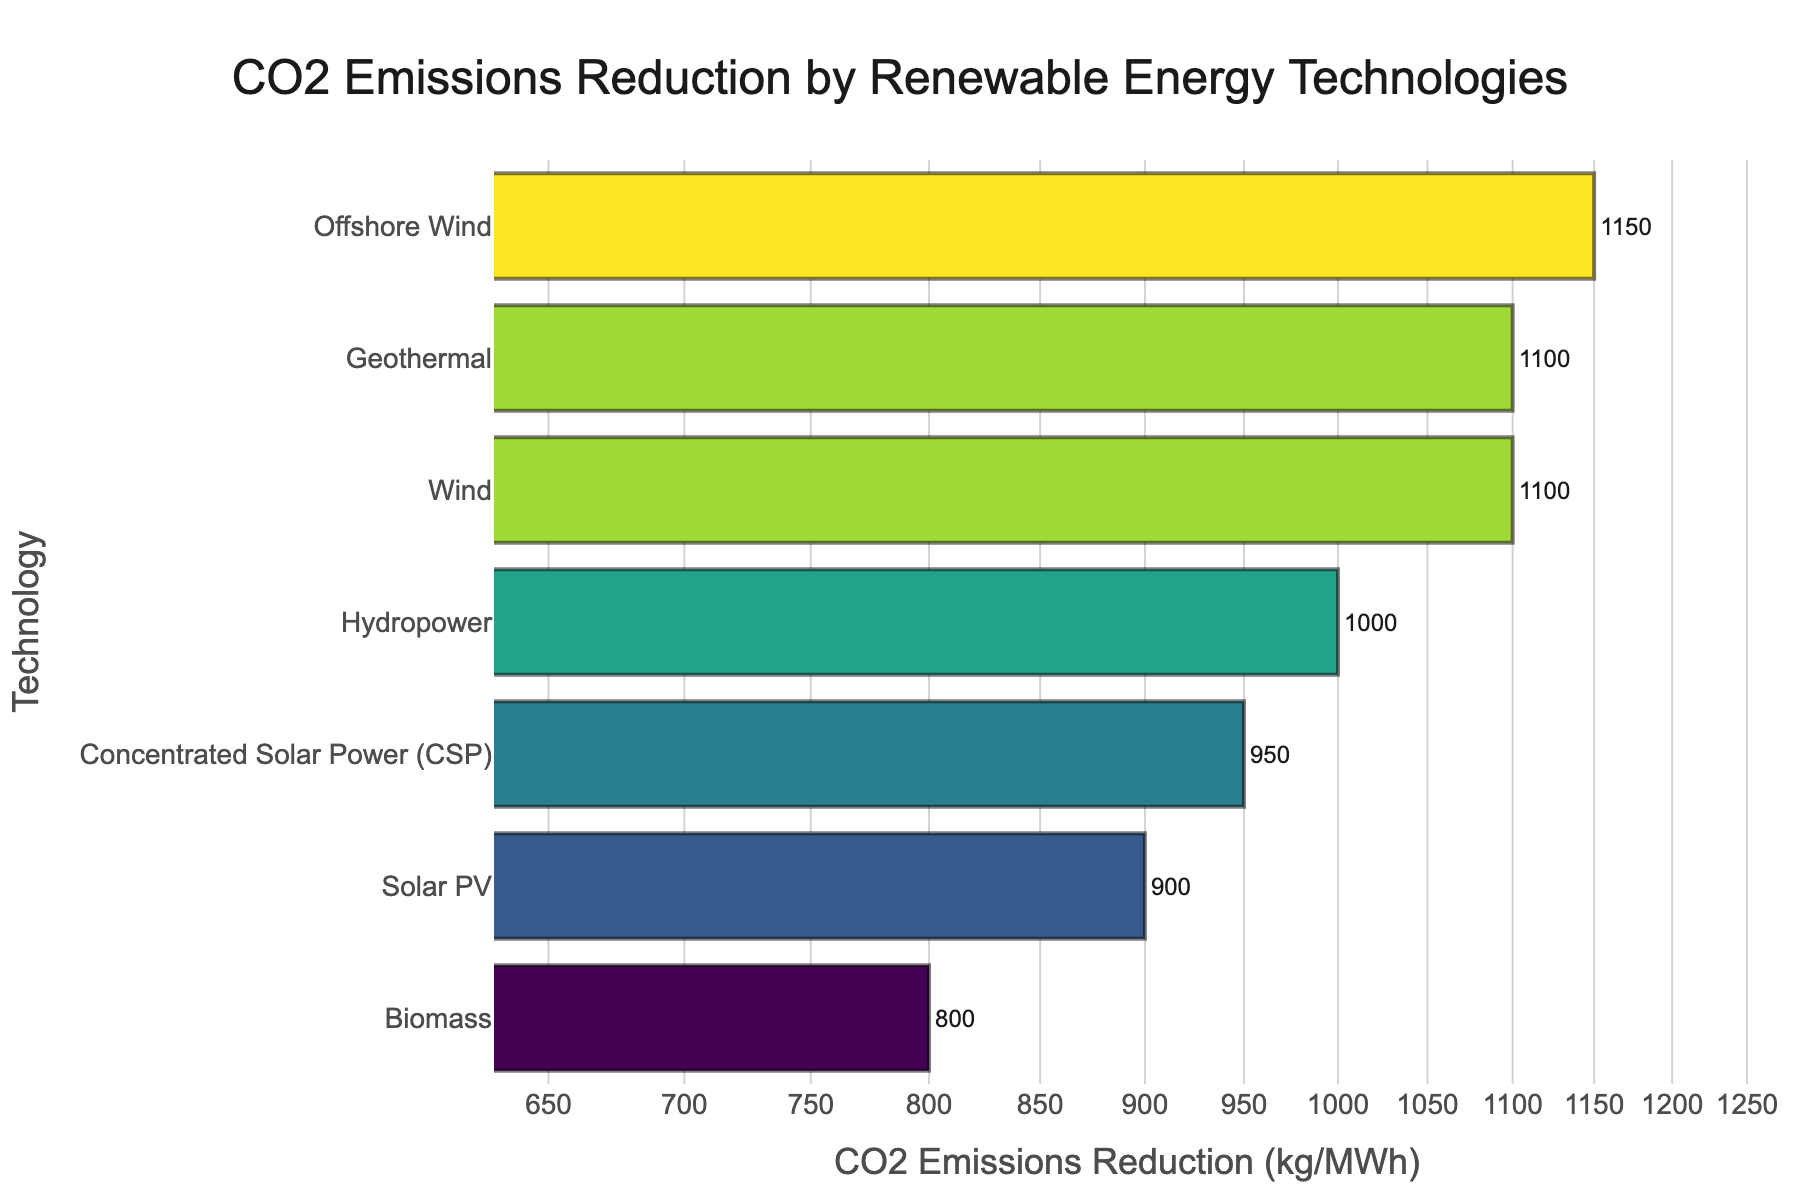What is the title of the figure? The title of the figure is prominently displayed at the top.
Answer: CO2 Emissions Reduction by Renewable Energy Technologies Which technology achieves the highest CO2 emissions reduction? The technology with the highest CO2 emissions reduction is positioned at the far right of the plot's x-axis.
Answer: Offshore Wind How many technologies have CO2 emissions reductions greater than 1000 kg/MWh? Count the number of bars where the CO2 emissions reduction exceeds 1000 kg/MWh.
Answer: 3 Which two technologies have exactly the same amount of CO2 emissions reduction? Identify the technologies with bars that align at the same x-axis value.
Answer: Wind, Geothermal By how much does Offshore Wind reduce more CO2 emissions compared to Biomass? Subtract Biomass's CO2 emissions reduction from Offshore Wind's CO2 emissions reduction. Offshore Wind reduces 1150 kg/MWh and Biomass reduces 800 kg/MWh. 1150 - 800 = 350
Answer: 350 kg/MWh What's the average CO2 emissions reduction for Solar PV, Wind, and Hydropower? Add the CO2 emissions reductions achieved by Solar PV (900), Wind (1100), and Hydropower (1000). Then, divide by 3. (900 + 1100 + 1000) / 3 = 1000
Answer: 1000 kg/MWh Which technology reduces the least amount of CO2 emissions? The technology with the smallest bar value on the x-axis represents the least CO2 emissions reduction.
Answer: Biomass What is the range of CO2 emissions reductions achieved by all the technologies? Subtract the lowest CO2 emissions reduction value from the highest value. Highest: 1150 (Offshore Wind), Lowest: 800 (Biomass), Range: 1150 - 800 = 350
Answer: 350 kg/MWh Are there more technologies that reduce CO2 emissions below 1000 kg/MWh or above 1000 kg/MWh? Count the number of bars below and above 1000 kg/MWh.
Answer: Below: 3, Above: 4 